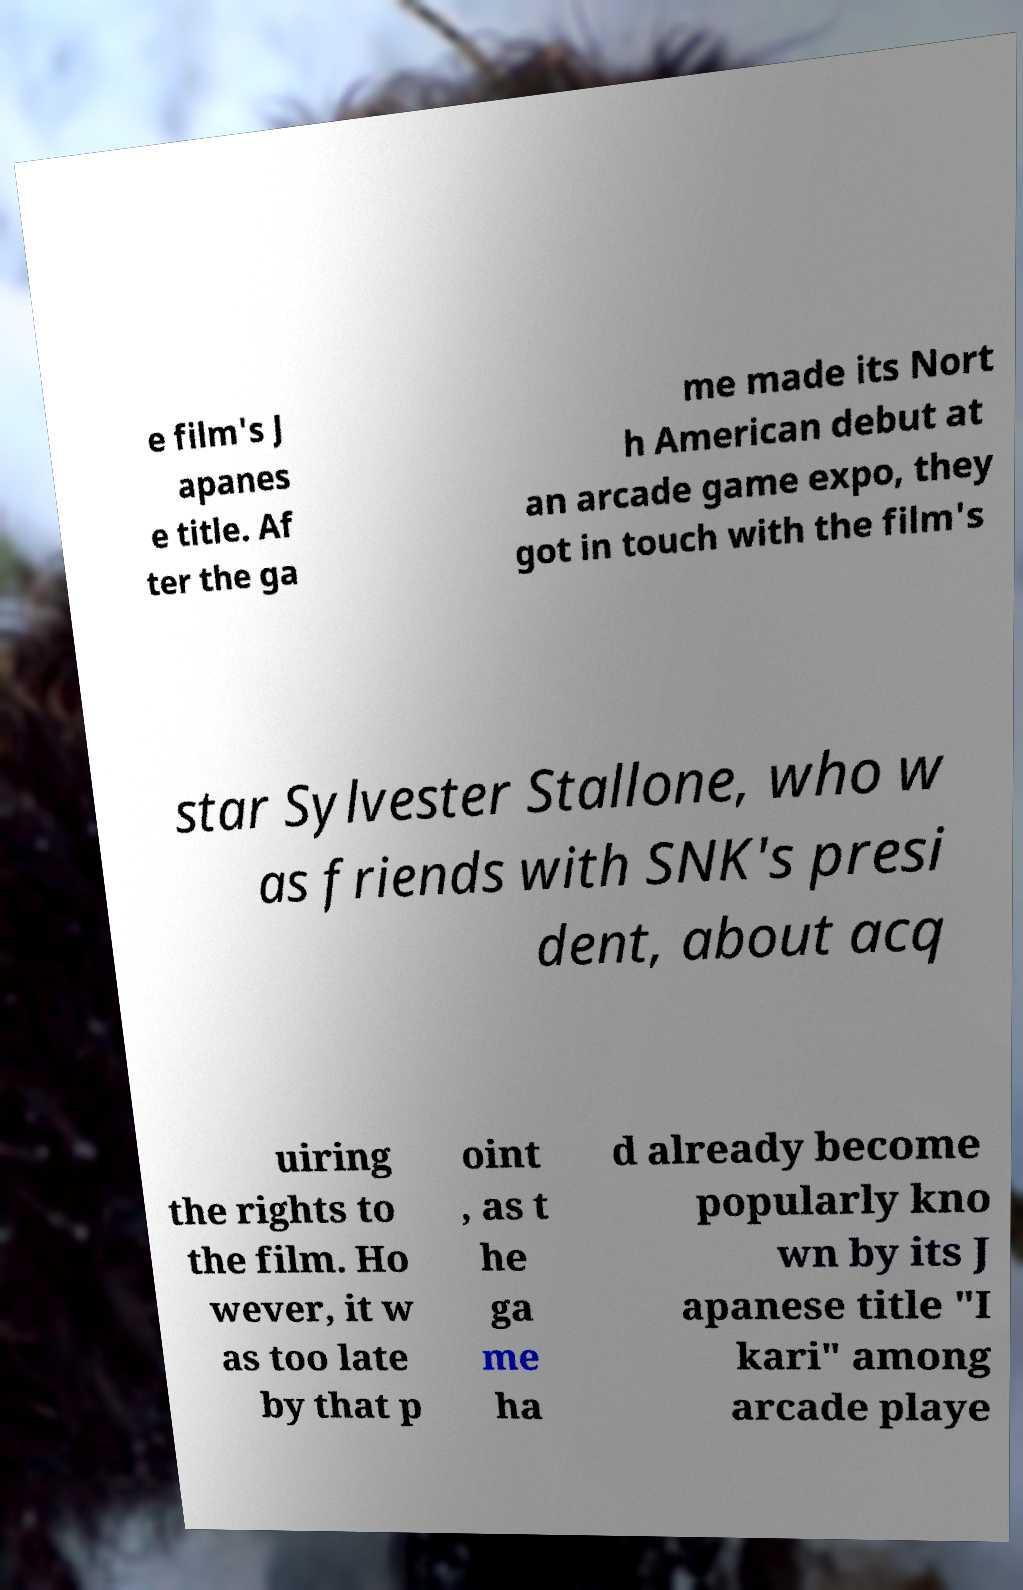Please identify and transcribe the text found in this image. e film's J apanes e title. Af ter the ga me made its Nort h American debut at an arcade game expo, they got in touch with the film's star Sylvester Stallone, who w as friends with SNK's presi dent, about acq uiring the rights to the film. Ho wever, it w as too late by that p oint , as t he ga me ha d already become popularly kno wn by its J apanese title "I kari" among arcade playe 